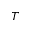Convert formula to latex. <formula><loc_0><loc_0><loc_500><loc_500>T</formula> 